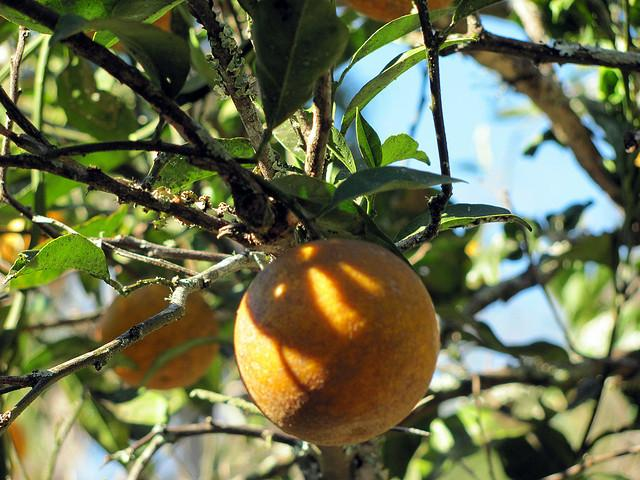Which acid is present in orange?

Choices:
A) tannic acid
B) citric acid
C) tartaric acid
D) amino acid citric acid 